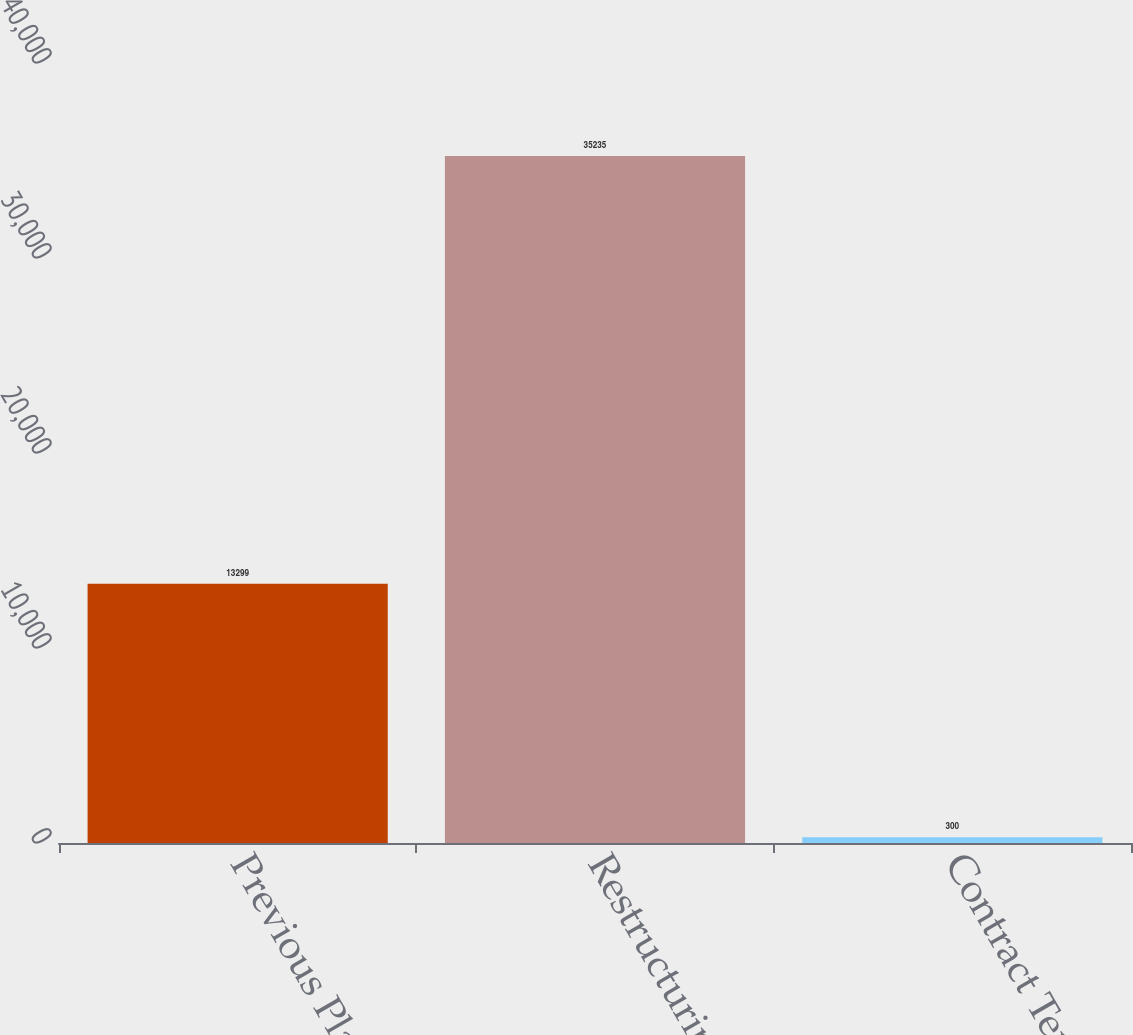Convert chart to OTSL. <chart><loc_0><loc_0><loc_500><loc_500><bar_chart><fcel>Previous Plans (4)<fcel>Restructuring<fcel>Contract Termination<nl><fcel>13299<fcel>35235<fcel>300<nl></chart> 